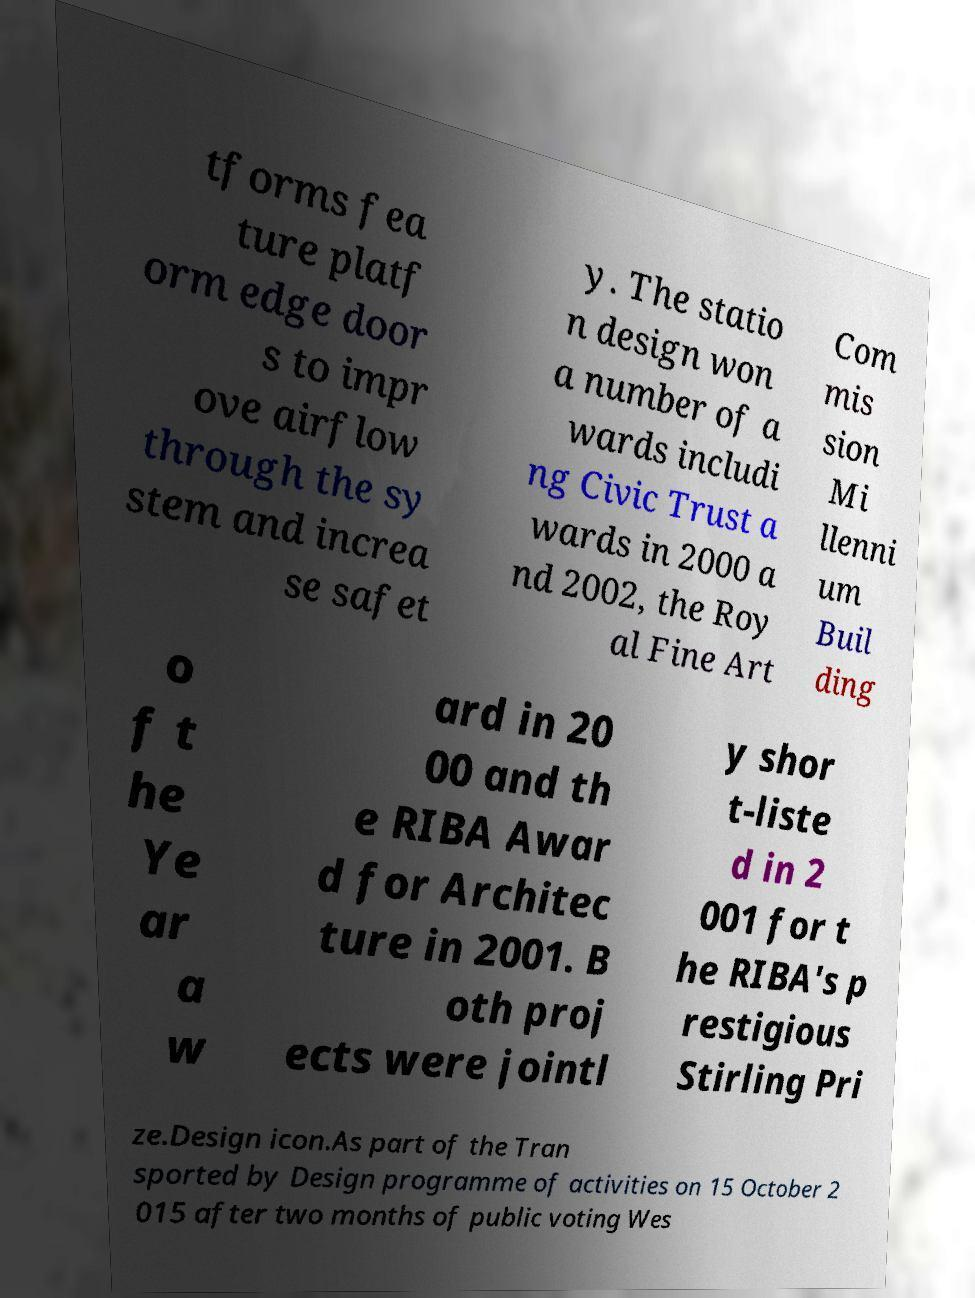Can you read and provide the text displayed in the image?This photo seems to have some interesting text. Can you extract and type it out for me? tforms fea ture platf orm edge door s to impr ove airflow through the sy stem and increa se safet y. The statio n design won a number of a wards includi ng Civic Trust a wards in 2000 a nd 2002, the Roy al Fine Art Com mis sion Mi llenni um Buil ding o f t he Ye ar a w ard in 20 00 and th e RIBA Awar d for Architec ture in 2001. B oth proj ects were jointl y shor t-liste d in 2 001 for t he RIBA's p restigious Stirling Pri ze.Design icon.As part of the Tran sported by Design programme of activities on 15 October 2 015 after two months of public voting Wes 